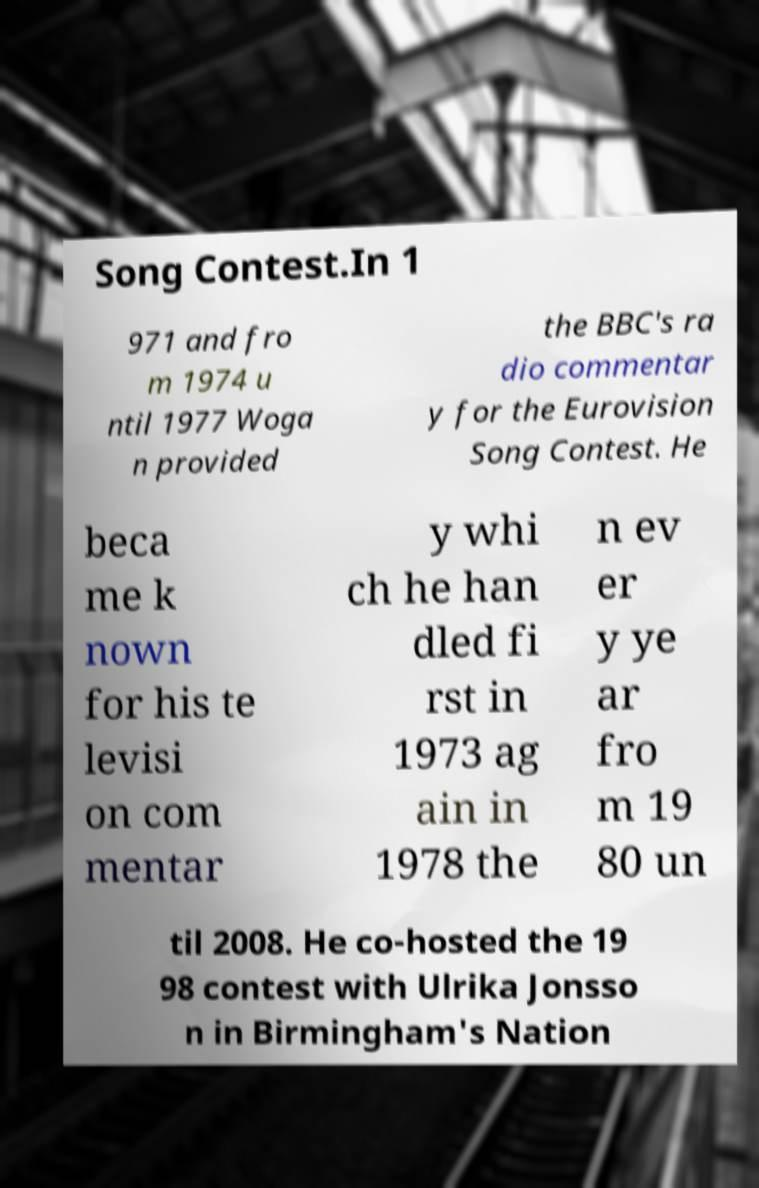Can you read and provide the text displayed in the image?This photo seems to have some interesting text. Can you extract and type it out for me? Song Contest.In 1 971 and fro m 1974 u ntil 1977 Woga n provided the BBC's ra dio commentar y for the Eurovision Song Contest. He beca me k nown for his te levisi on com mentar y whi ch he han dled fi rst in 1973 ag ain in 1978 the n ev er y ye ar fro m 19 80 un til 2008. He co-hosted the 19 98 contest with Ulrika Jonsso n in Birmingham's Nation 